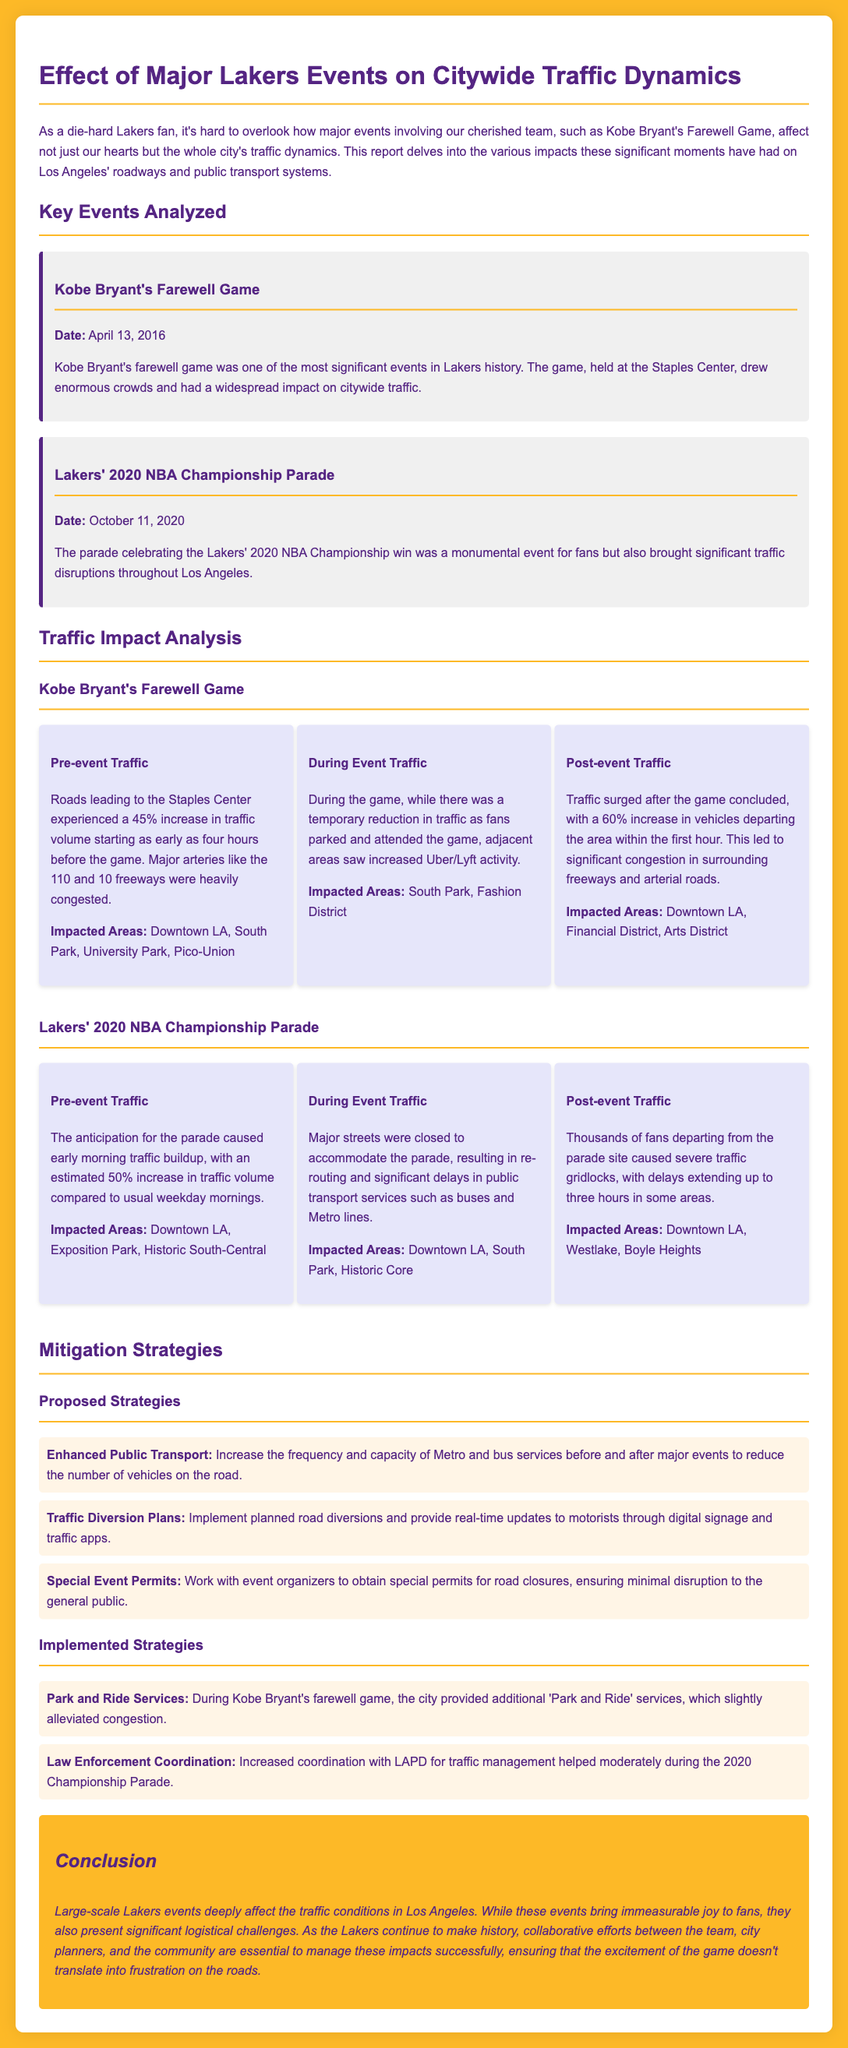what was the date of Kobe Bryant's farewell game? The date of Kobe Bryant's farewell game is specified as April 13, 2016.
Answer: April 13, 2016 what percentage increase in traffic was seen before Kobe Bryant's farewell game? The document states that there was a 45% increase in traffic volume before the game.
Answer: 45% which area experienced congestion post Kobe Bryant's farewell game? The affected areas listed in the document include Downtown LA, Financial District, and Arts District after the game.
Answer: Downtown LA, Financial District, Arts District what was the traffic increase percentage during the Lakers' 2020 Championship Parade? The report mentions a 50% increase in traffic volume in anticipation of the parade.
Answer: 50% how many hours of delay were reported post the Lakers' 2020 Championship Parade? The document indicates that delays extended up to three hours in some areas after the parade concluded.
Answer: three hours what strategy was implemented during Kobe Bryant's farewell game to alleviate congestion? The document states that additional 'Park and Ride' services were provided to help alleviate congestion.
Answer: 'Park and Ride' services what major streets were closed during the Lakers' 2020 NBA Championship Parade? The document specifies that major streets were closed to accommodate the parade; however, it does not name specific streets.
Answer: Major streets what approach is suggested for traffic management during major Lakers events? Proposed strategies include increasing public transport services and implementing traffic diversion plans during major events.
Answer: Traffic diversion plans 